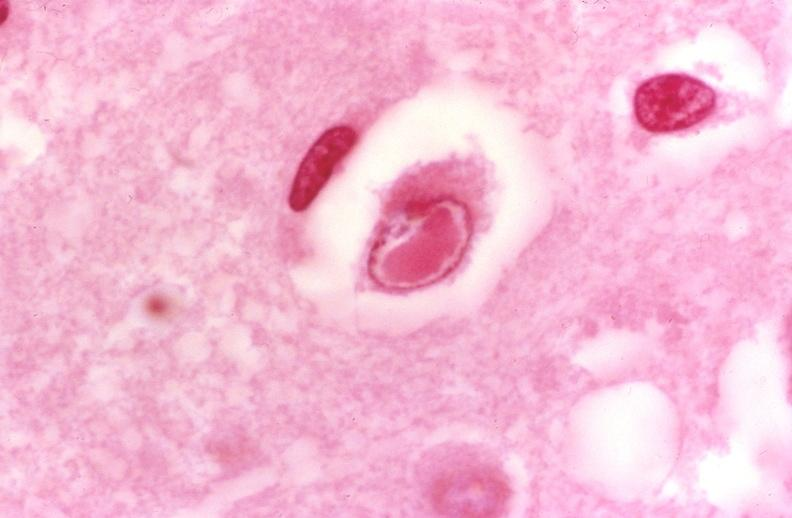what does this image show?
Answer the question using a single word or phrase. Brain 